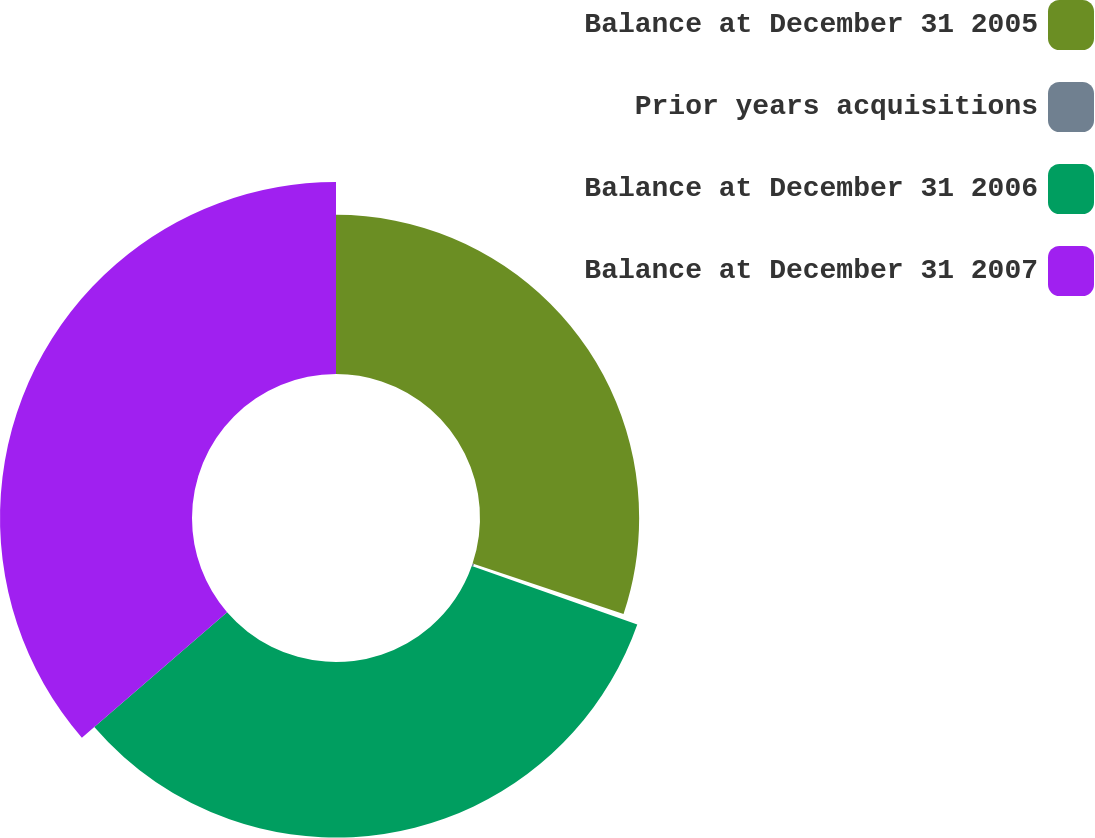Convert chart to OTSL. <chart><loc_0><loc_0><loc_500><loc_500><pie_chart><fcel>Balance at December 31 2005<fcel>Prior years acquisitions<fcel>Balance at December 31 2006<fcel>Balance at December 31 2007<nl><fcel>30.13%<fcel>0.28%<fcel>33.24%<fcel>36.35%<nl></chart> 